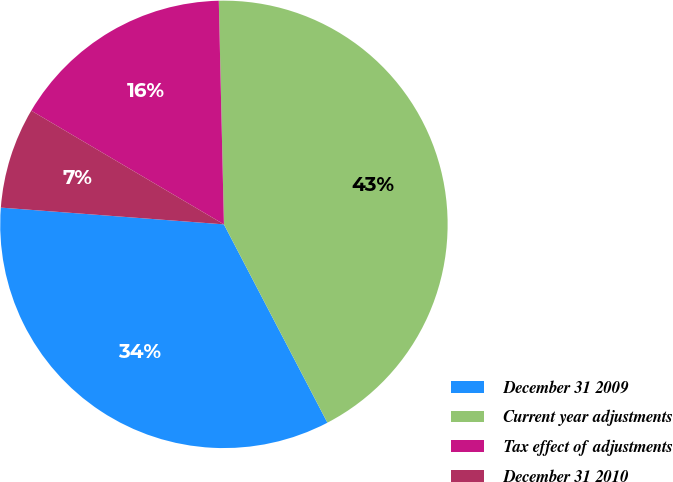<chart> <loc_0><loc_0><loc_500><loc_500><pie_chart><fcel>December 31 2009<fcel>Current year adjustments<fcel>Tax effect of adjustments<fcel>December 31 2010<nl><fcel>33.85%<fcel>42.71%<fcel>16.15%<fcel>7.29%<nl></chart> 